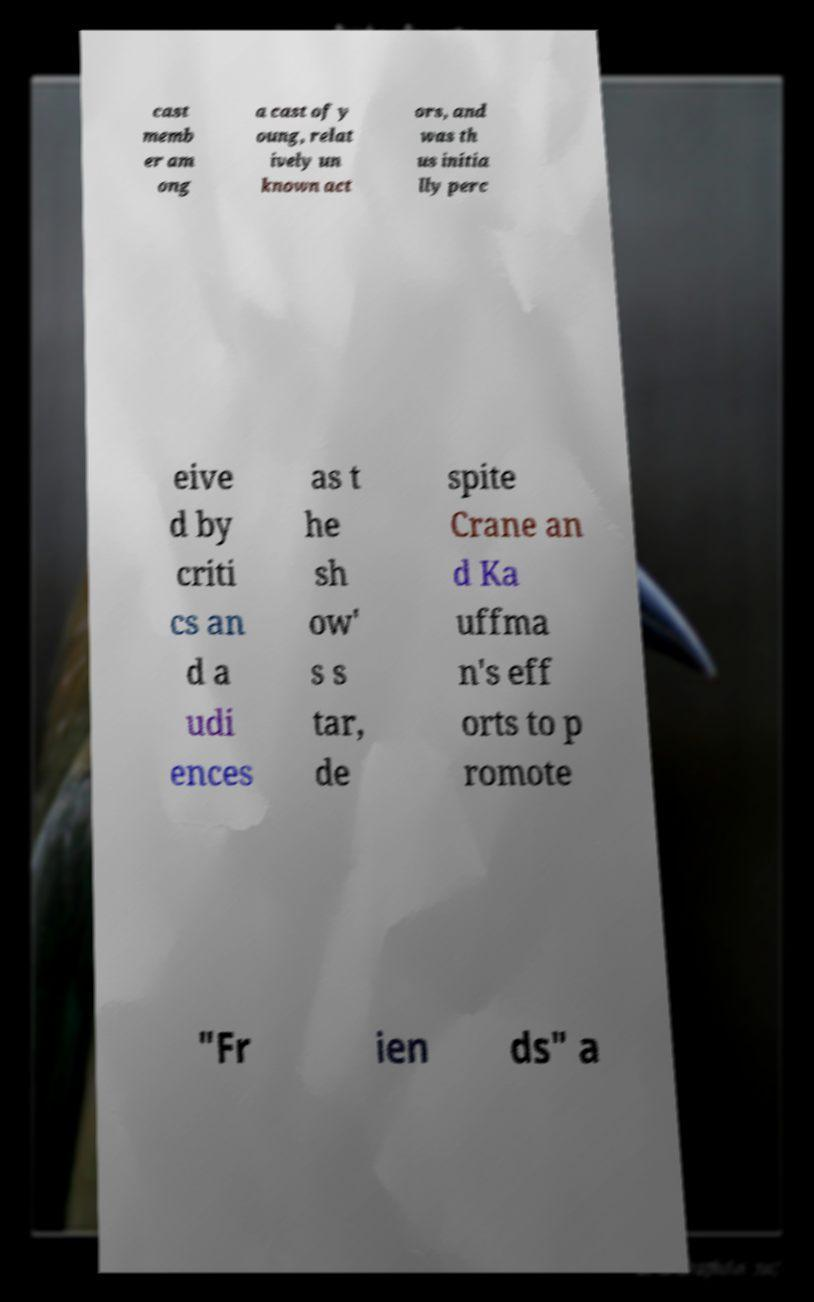Could you assist in decoding the text presented in this image and type it out clearly? cast memb er am ong a cast of y oung, relat ively un known act ors, and was th us initia lly perc eive d by criti cs an d a udi ences as t he sh ow' s s tar, de spite Crane an d Ka uffma n's eff orts to p romote "Fr ien ds" a 